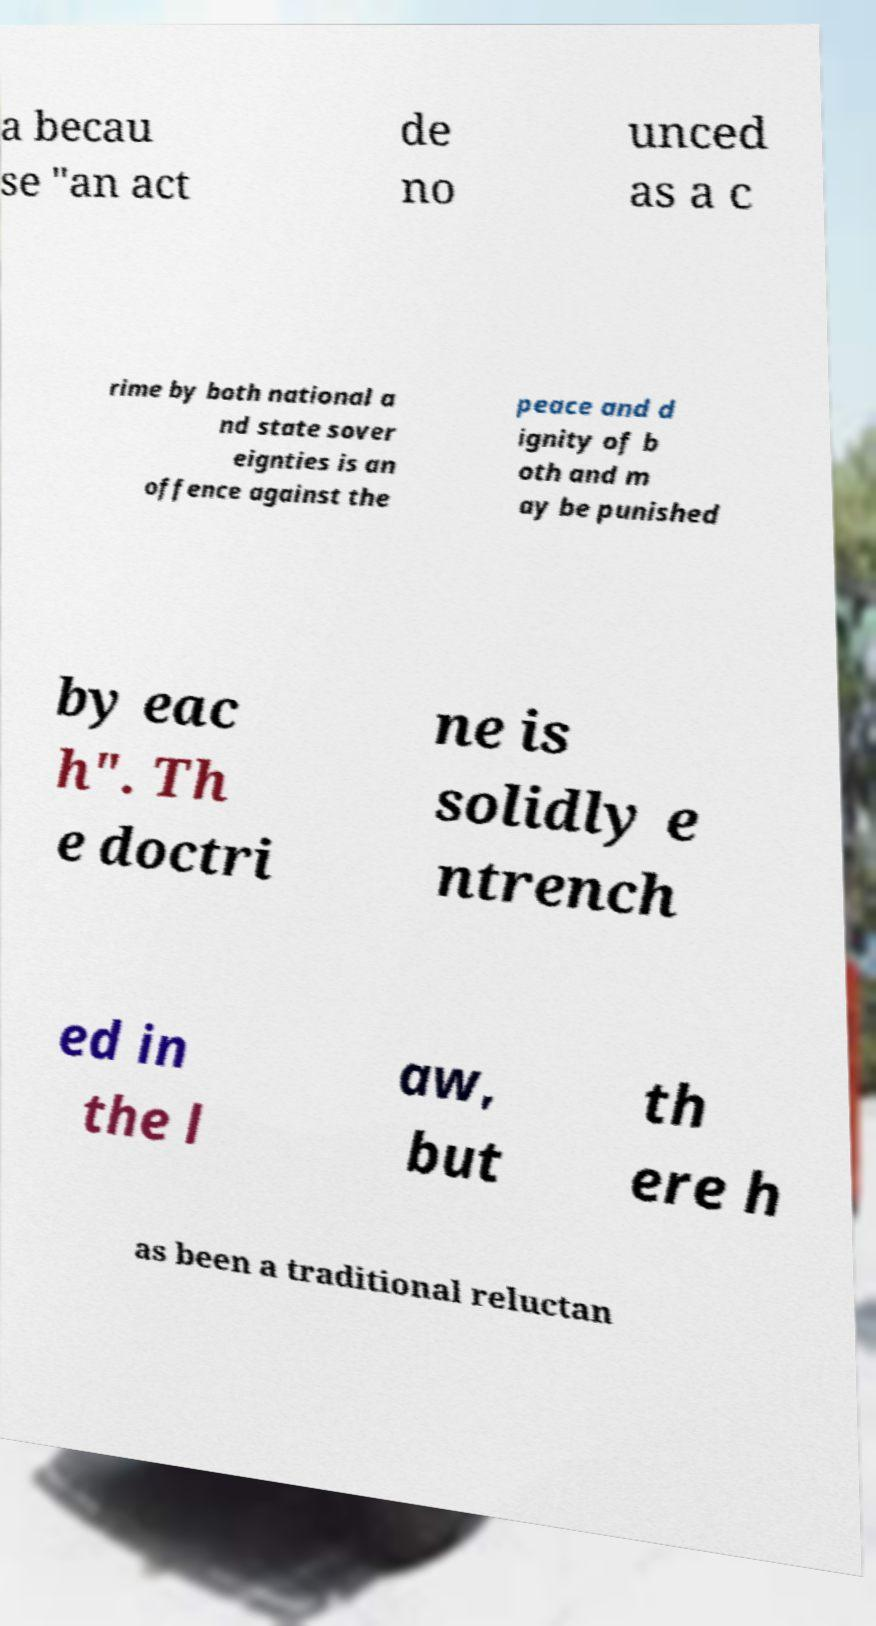Can you accurately transcribe the text from the provided image for me? a becau se "an act de no unced as a c rime by both national a nd state sover eignties is an offence against the peace and d ignity of b oth and m ay be punished by eac h". Th e doctri ne is solidly e ntrench ed in the l aw, but th ere h as been a traditional reluctan 